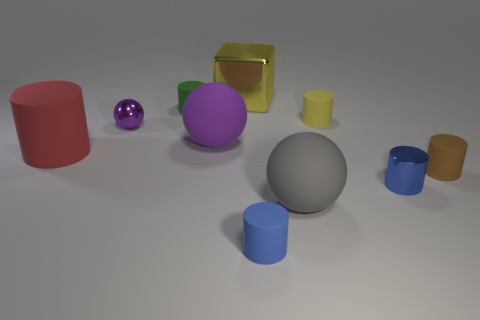Subtract all large cylinders. How many cylinders are left? 5 Subtract all brown cylinders. How many cylinders are left? 5 Subtract 1 cylinders. How many cylinders are left? 5 Subtract all gray cylinders. Subtract all brown blocks. How many cylinders are left? 6 Subtract all cubes. How many objects are left? 9 Subtract 0 red blocks. How many objects are left? 10 Subtract all large red metallic cylinders. Subtract all large yellow shiny cubes. How many objects are left? 9 Add 4 blue matte cylinders. How many blue matte cylinders are left? 5 Add 7 large yellow rubber blocks. How many large yellow rubber blocks exist? 7 